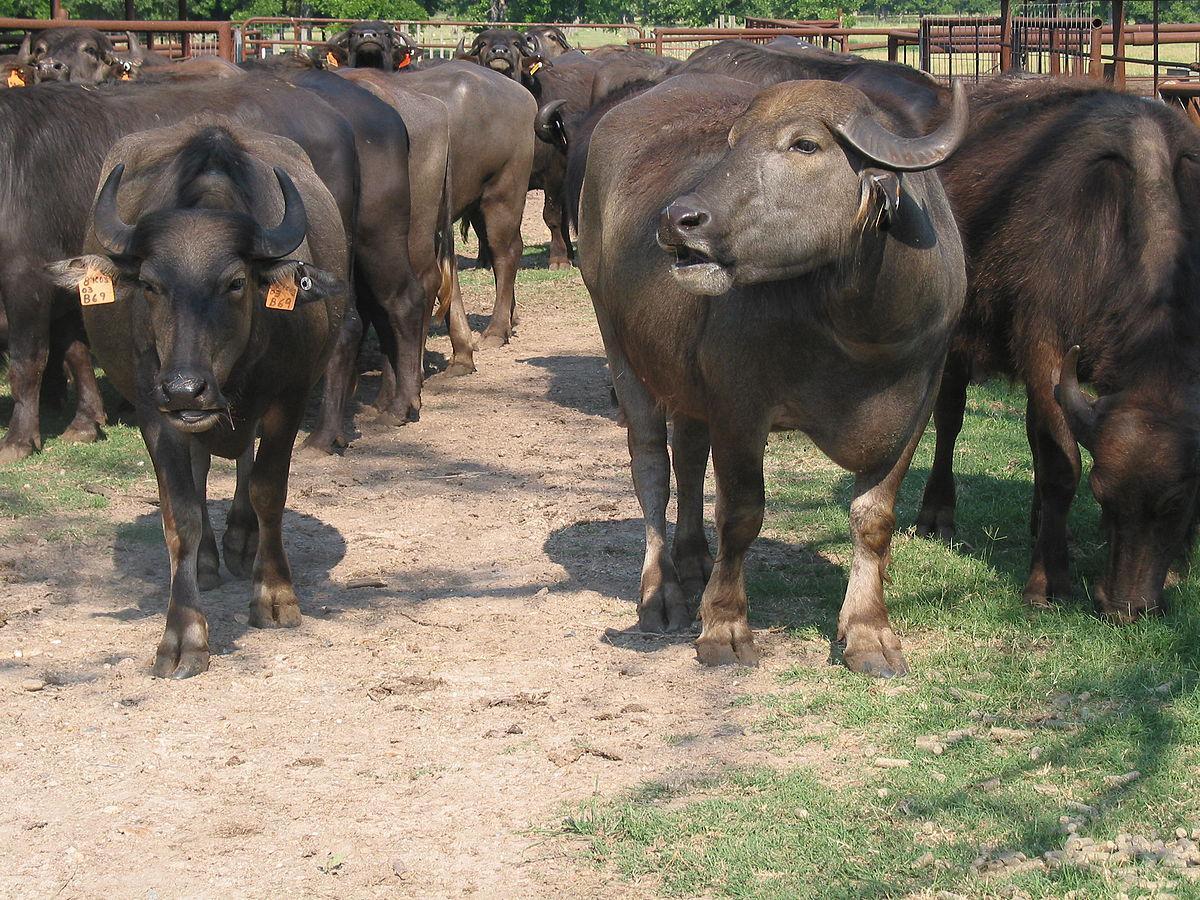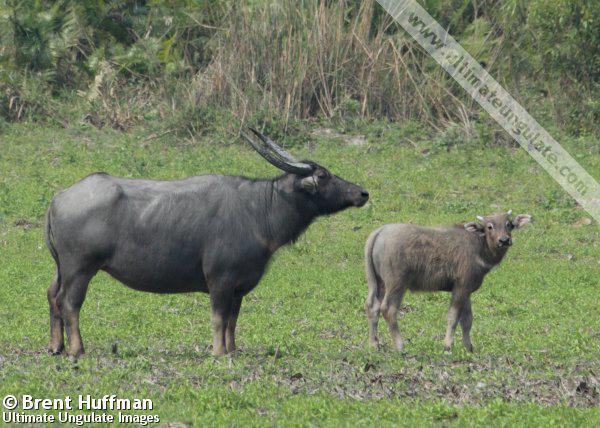The first image is the image on the left, the second image is the image on the right. For the images shown, is this caption "One image shows just one ox, and it has rope threaded through its nose." true? Answer yes or no. No. 